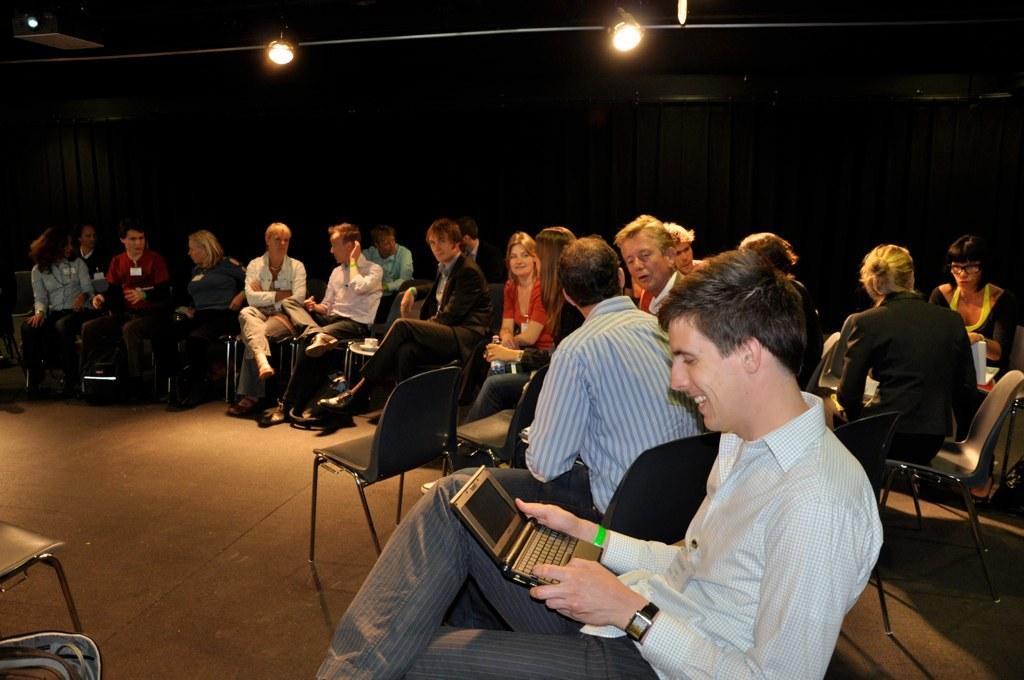How would you summarize this image in a sentence or two? In this image we can see many persons sitting on the chairs. In the background we can see curtain and lights. 